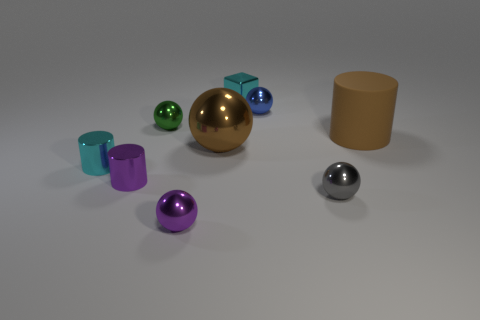Are there any other things that are the same material as the big cylinder?
Provide a short and direct response. No. Are there an equal number of purple metal spheres on the right side of the large brown metal ball and small metal cylinders on the left side of the cyan cylinder?
Provide a short and direct response. Yes. What shape is the small metal thing that is behind the tiny gray thing and in front of the small cyan metallic cylinder?
Provide a short and direct response. Cylinder. There is a big brown sphere; how many cyan things are on the right side of it?
Provide a short and direct response. 1. How many other things are there of the same shape as the green thing?
Provide a short and direct response. 4. Are there fewer large matte things than big cyan metallic objects?
Give a very brief answer. No. How big is the metal thing that is on the left side of the blue object and behind the tiny green metal ball?
Keep it short and to the point. Small. How big is the cyan thing that is on the left side of the tiny purple metal sphere in front of the cyan metallic object left of the brown shiny sphere?
Make the answer very short. Small. The blue thing has what size?
Provide a succinct answer. Small. Is there a purple metallic thing behind the small cylinder that is in front of the cyan metallic object in front of the cube?
Your response must be concise. No. 